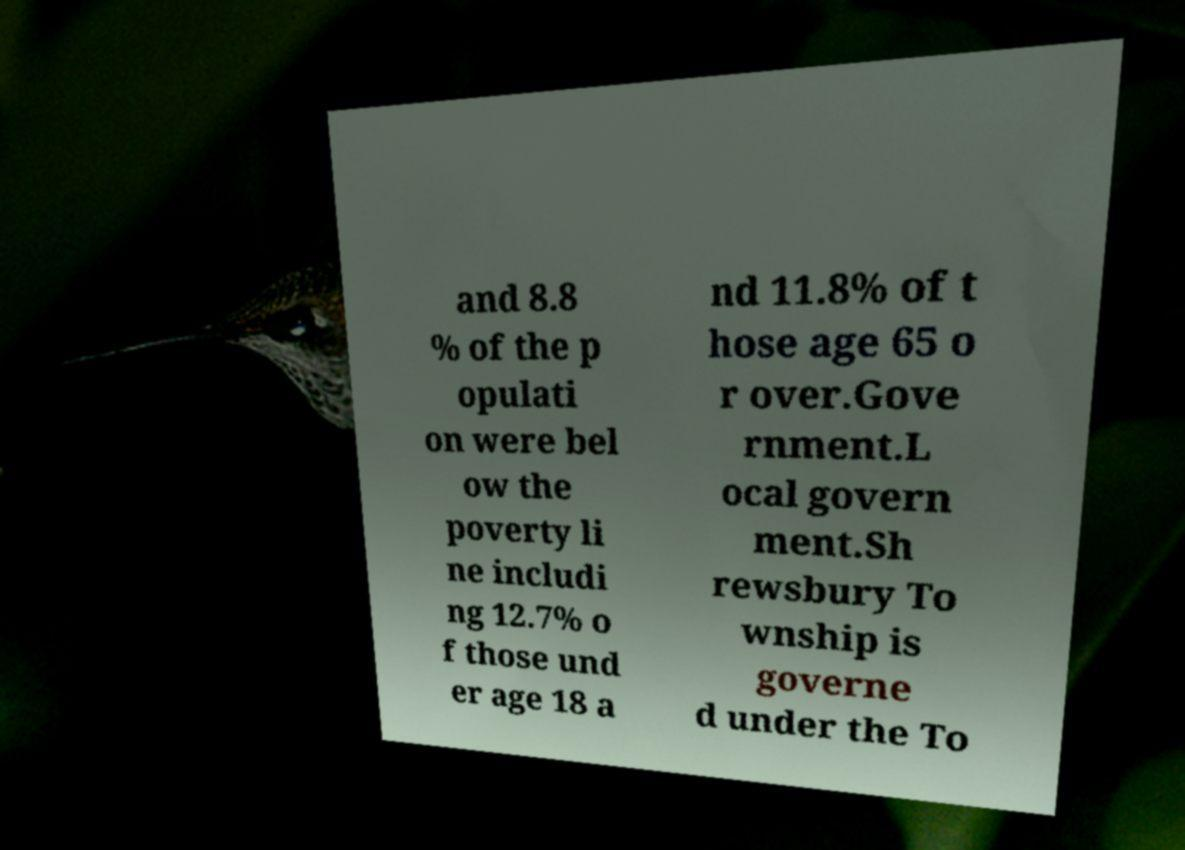Could you extract and type out the text from this image? and 8.8 % of the p opulati on were bel ow the poverty li ne includi ng 12.7% o f those und er age 18 a nd 11.8% of t hose age 65 o r over.Gove rnment.L ocal govern ment.Sh rewsbury To wnship is governe d under the To 